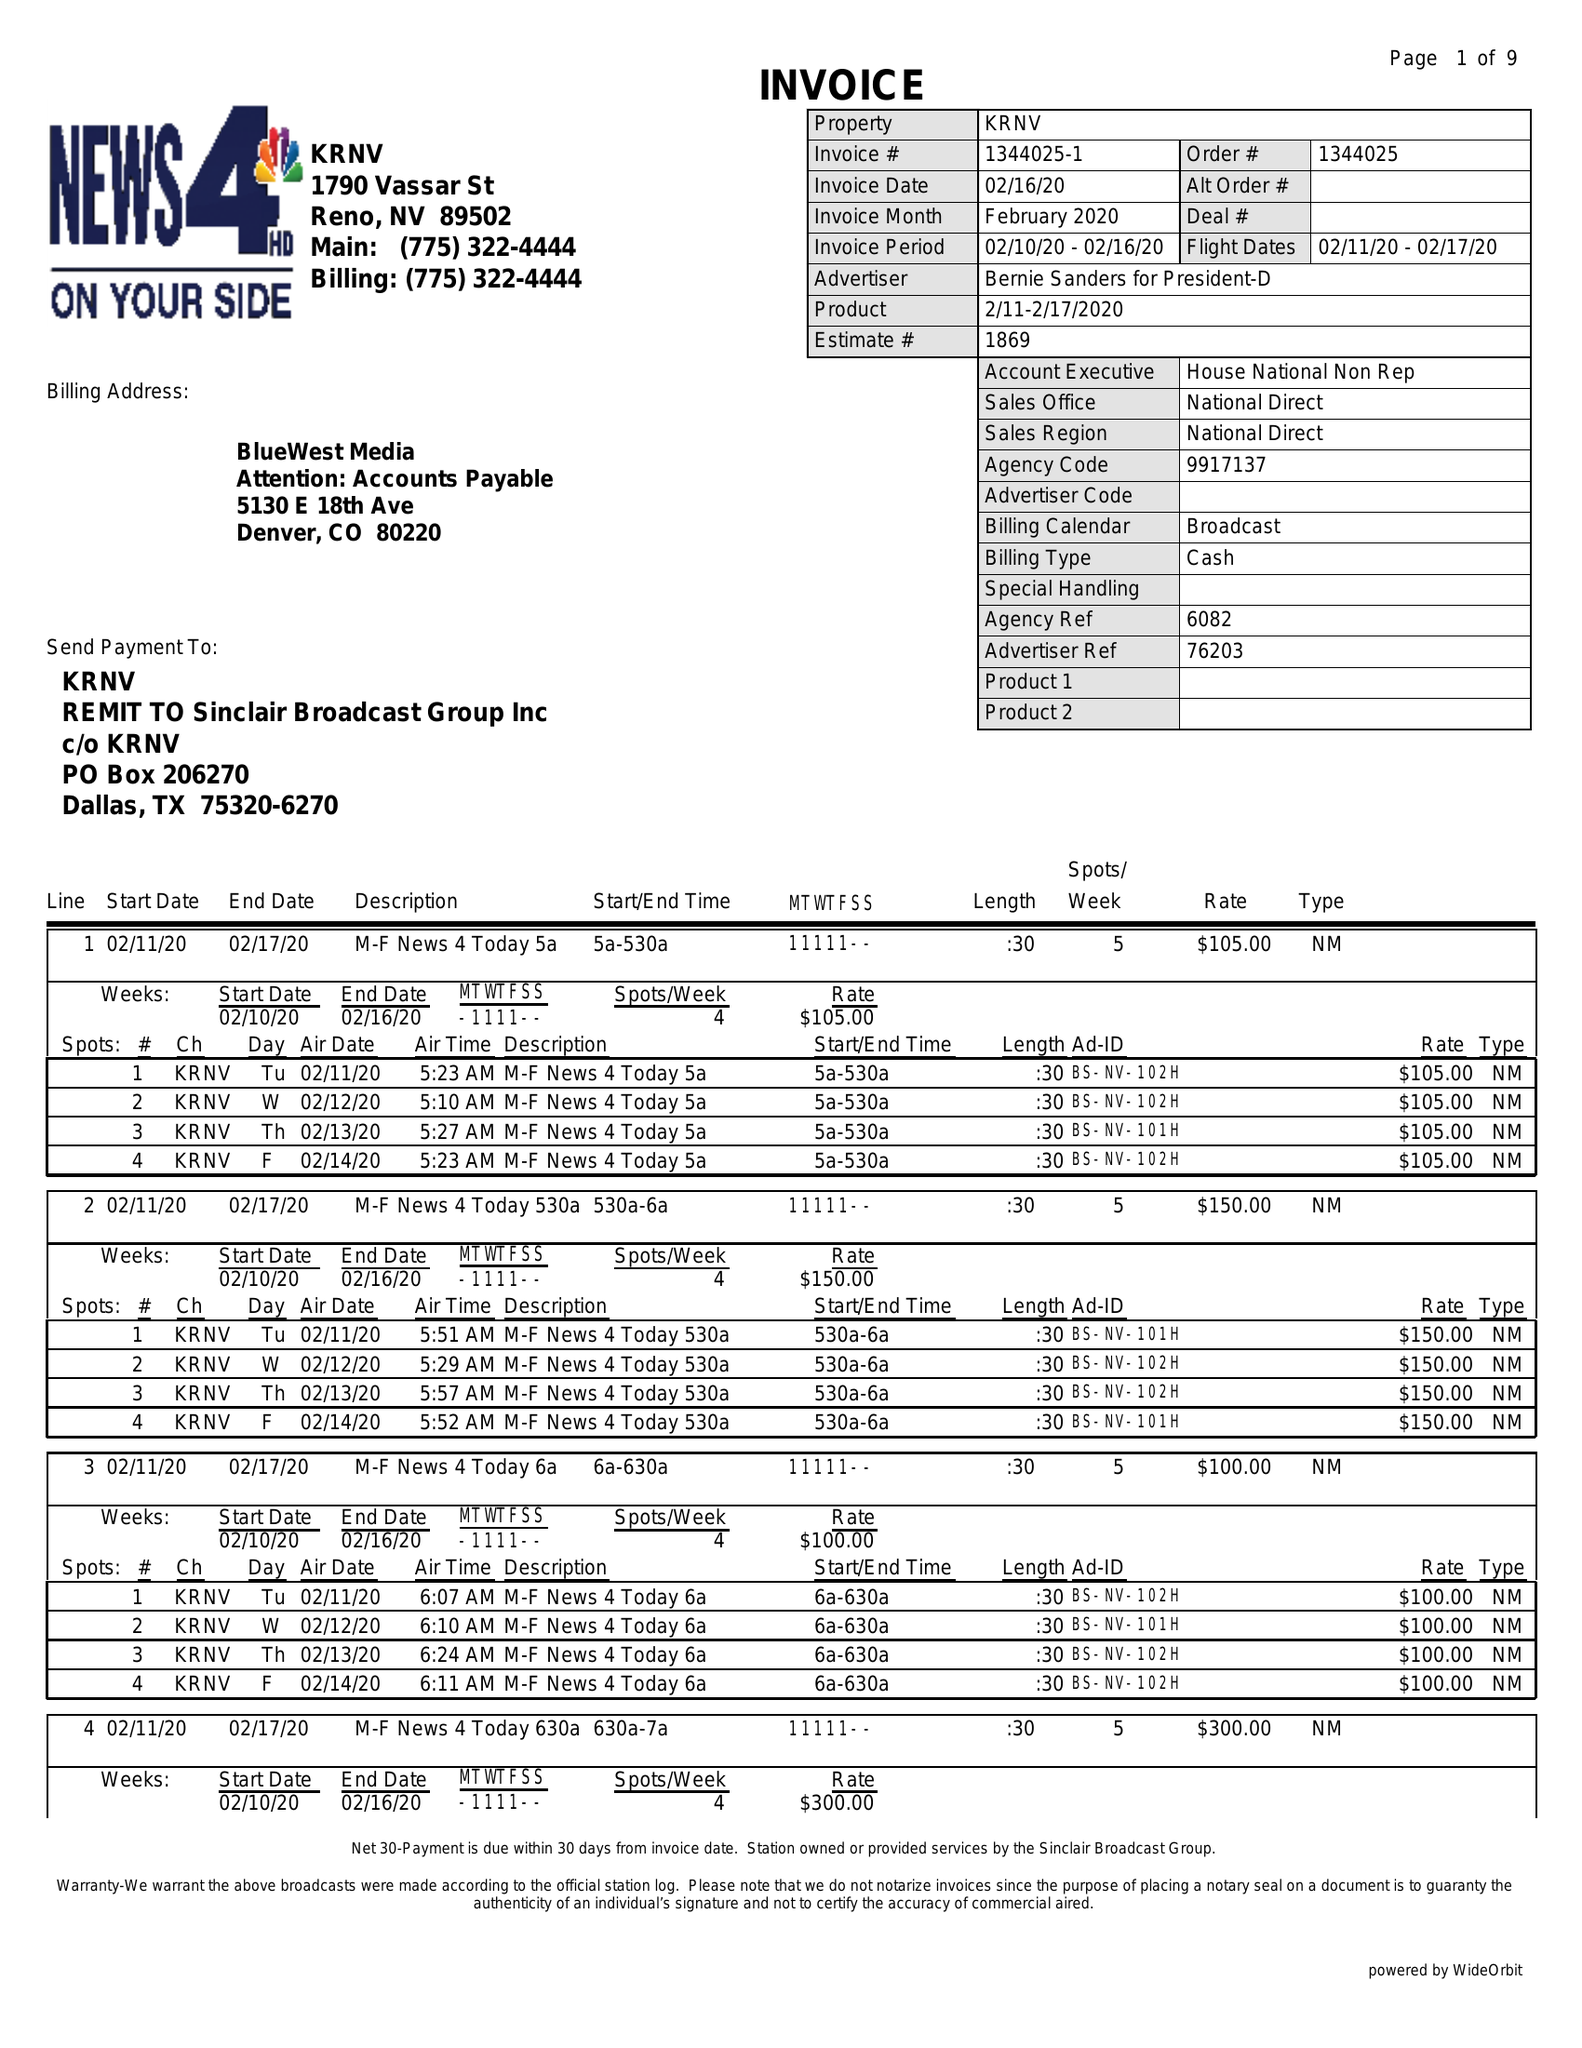What is the value for the flight_from?
Answer the question using a single word or phrase. 02/11/20 